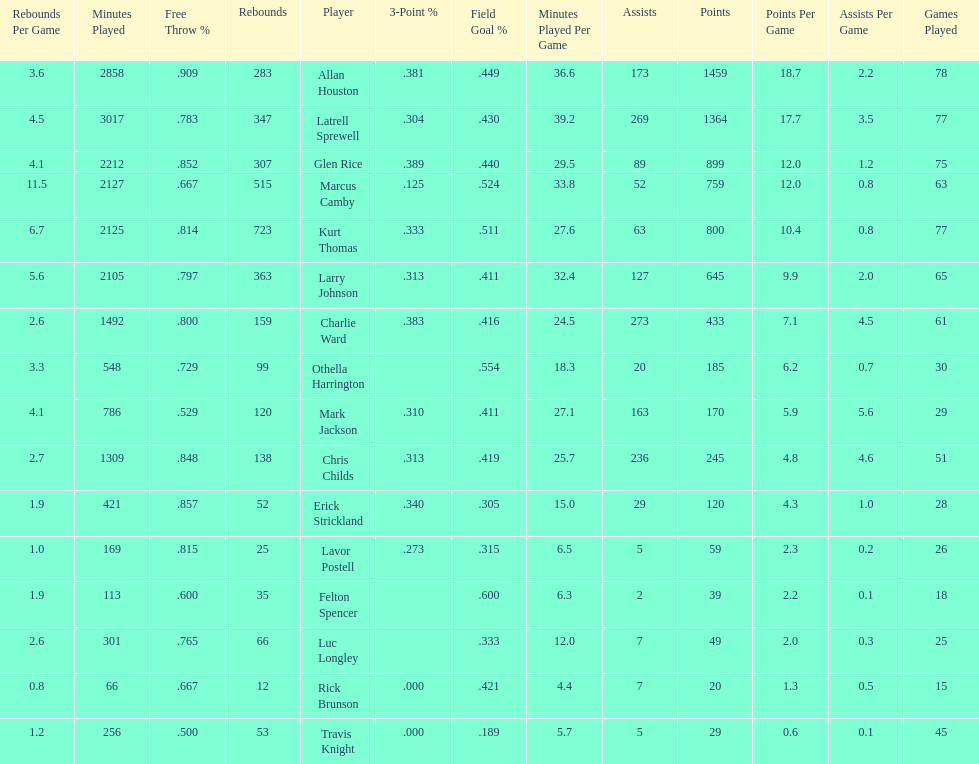Number of players on the team. 16. 